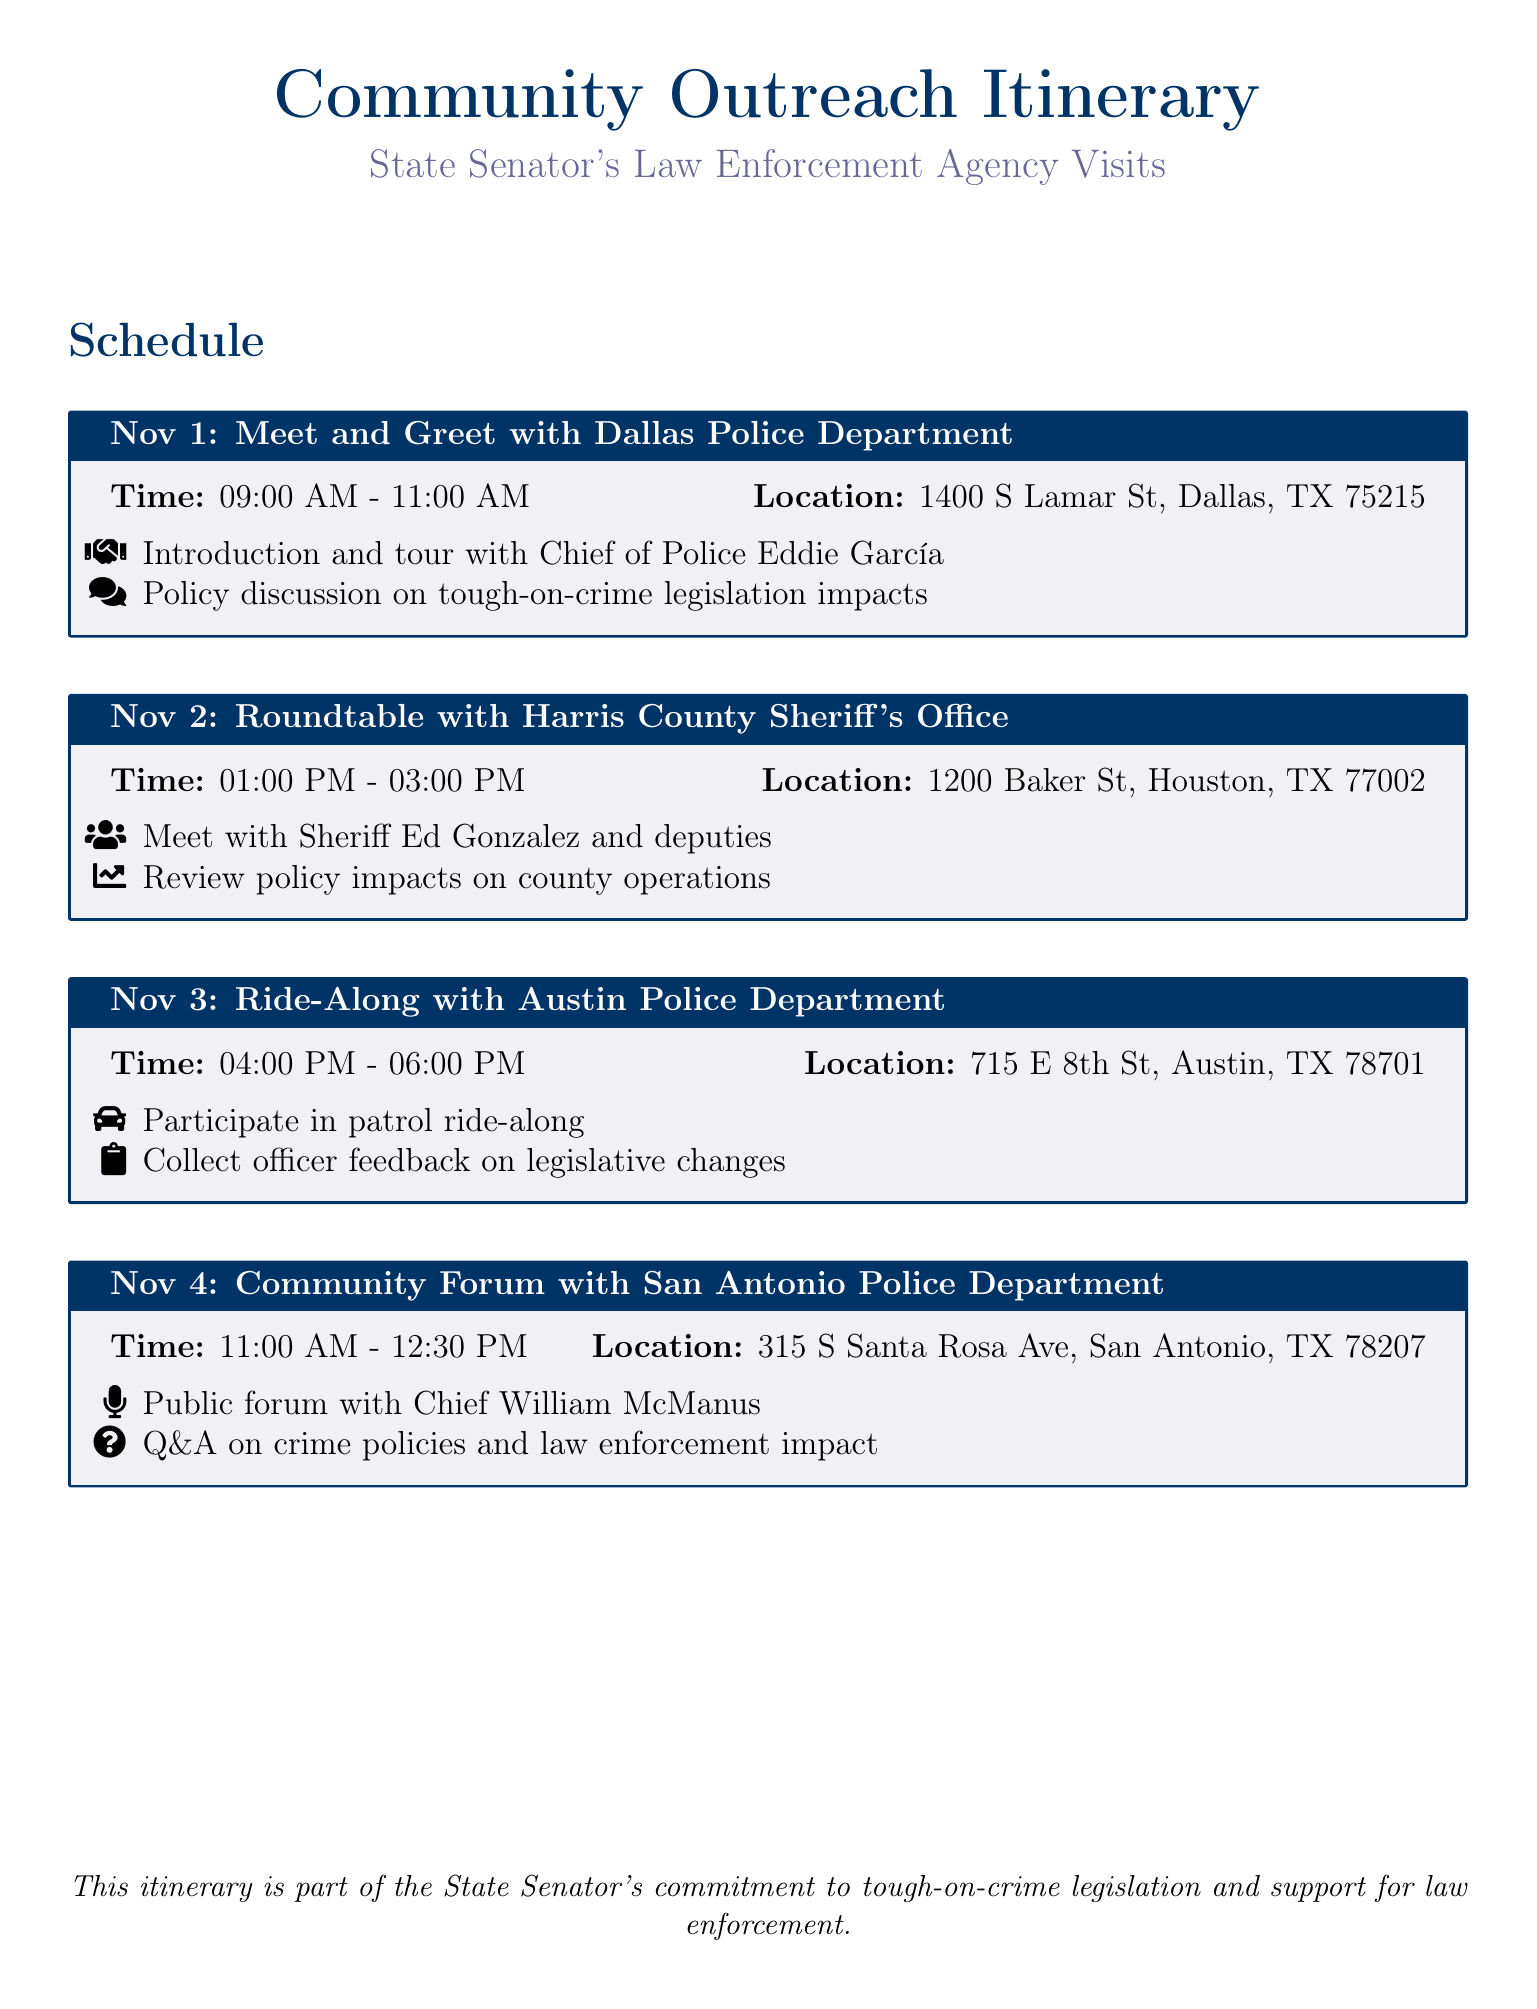What is the location of the meet and greet with the Dallas Police Department? The location is specified in the itinerary as 1400 S Lamar St, Dallas, TX 75215.
Answer: 1400 S Lamar St, Dallas, TX 75215 Who will host the roundtable with the Harris County Sheriff's Office? The itinerary mentions that Sheriff Ed Gonzalez will host the roundtable.
Answer: Sheriff Ed Gonzalez What is scheduled during the ride-along with the Austin Police Department? The itinerary lists participating in a patrol ride-along and collecting officer feedback.
Answer: Patrol ride-along and feedback collection What is the time for the community forum with the San Antonio Police Department? The time is stated as 11:00 AM - 12:30 PM in the itinerary.
Answer: 11:00 AM - 12:30 PM How many community outreach visits are mentioned in the itinerary? The itinerary lists a total of four community outreach visits.
Answer: Four What is the primary topic discussed with the Dallas Police Department? The primary topic of discussion is tough-on-crime legislation impacts.
Answer: Tough-on-crime legislation impacts What is the purpose of the itinerary? The purpose is to outline the State Senator's commitment to tough-on-crime legislation and support for law enforcement.
Answer: Commitment to tough-on-crime legislation What type of event is planned for Nov 4? The event planned is a community forum, as mentioned in the itinerary.
Answer: Community forum 